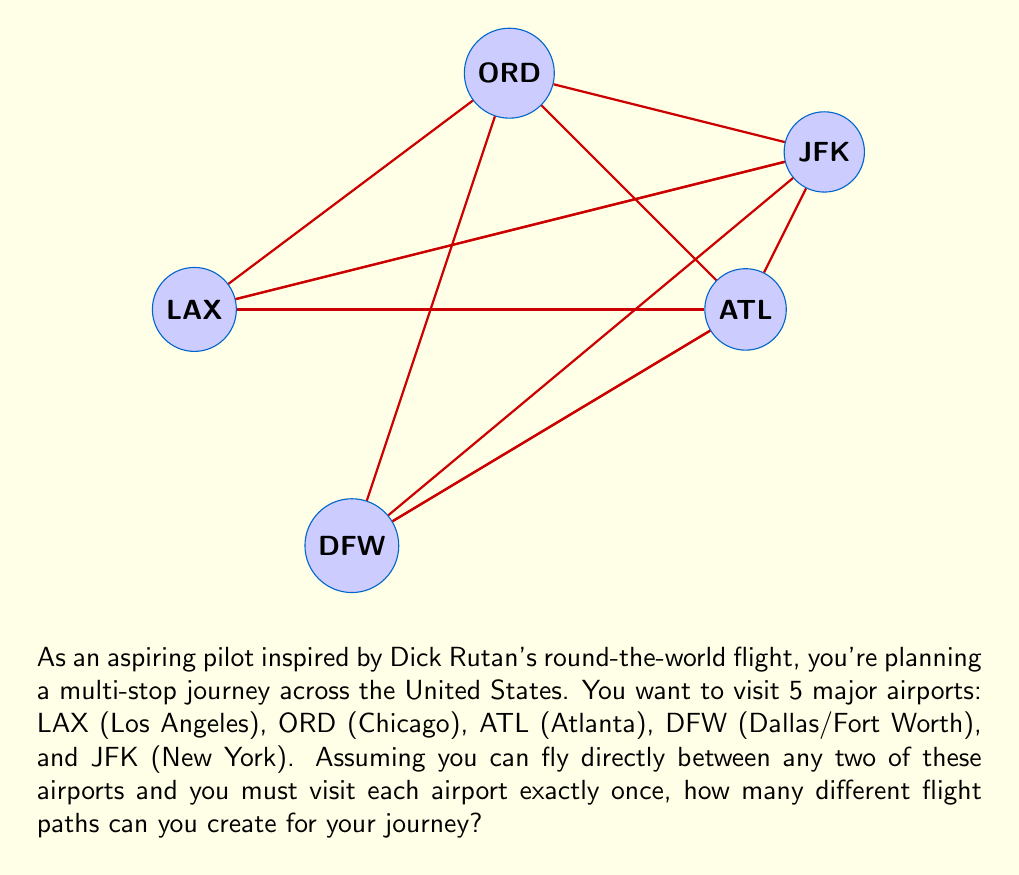Provide a solution to this math problem. Let's approach this step-by-step:

1) This problem is essentially asking for the number of permutations of 5 airports.

2) The formula for permutations of n distinct objects is:

   $$P(n) = n!$$

3) In this case, n = 5 (5 airports).

4) Therefore, we need to calculate:

   $$P(5) = 5!$$

5) Let's expand this:
   
   $$5! = 5 \times 4 \times 3 \times 2 \times 1 = 120$$

6) We can interpret this result as follows:
   - For the first airport, we have 5 choices
   - For the second airport, we have 4 remaining choices
   - For the third airport, we have 3 remaining choices
   - For the fourth airport, we have 2 remaining choices
   - For the last airport, we have only 1 choice left

7) Multiplying these choices together gives us the total number of possible flight paths:

   $$5 \times 4 \times 3 \times 2 \times 1 = 120$$

Therefore, there are 120 different possible flight paths for the journey.
Answer: 120 